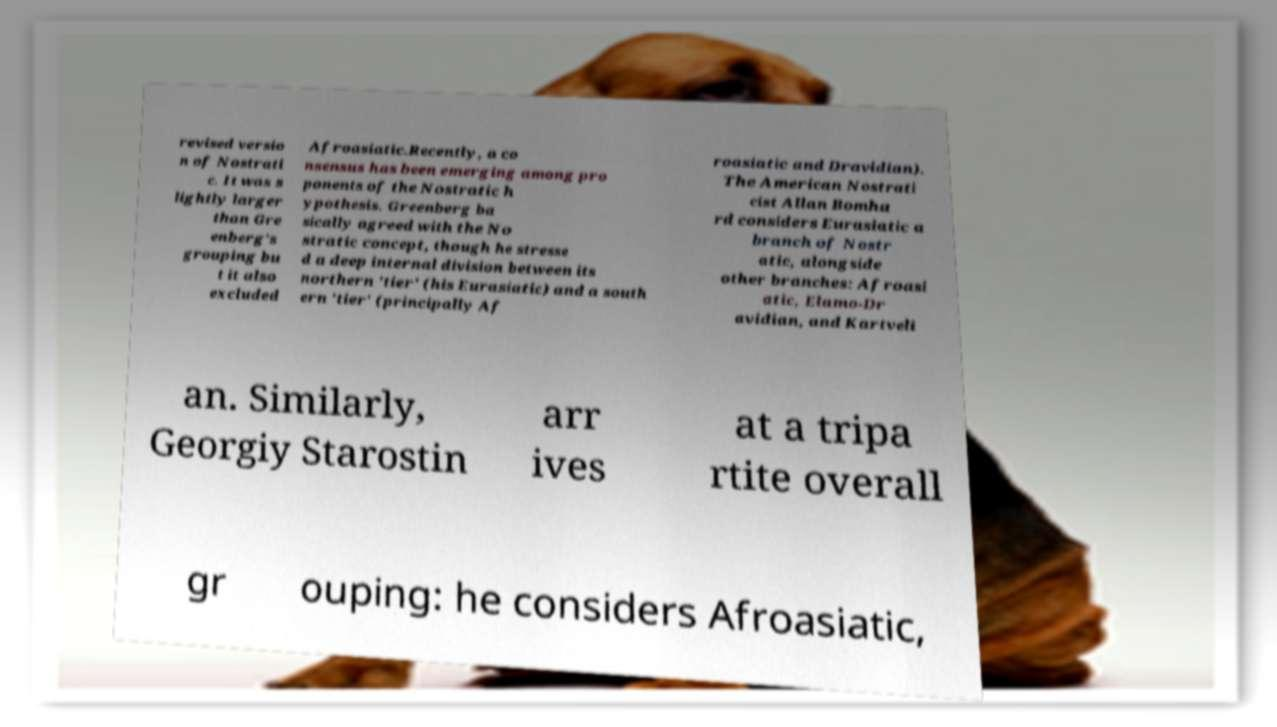Can you accurately transcribe the text from the provided image for me? revised versio n of Nostrati c. It was s lightly larger than Gre enberg's grouping bu t it also excluded Afroasiatic.Recently, a co nsensus has been emerging among pro ponents of the Nostratic h ypothesis. Greenberg ba sically agreed with the No stratic concept, though he stresse d a deep internal division between its northern 'tier' (his Eurasiatic) and a south ern 'tier' (principally Af roasiatic and Dravidian). The American Nostrati cist Allan Bomha rd considers Eurasiatic a branch of Nostr atic, alongside other branches: Afroasi atic, Elamo-Dr avidian, and Kartveli an. Similarly, Georgiy Starostin arr ives at a tripa rtite overall gr ouping: he considers Afroasiatic, 